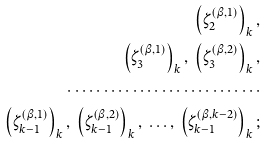<formula> <loc_0><loc_0><loc_500><loc_500>\left ( \zeta _ { 2 } ^ { ( \beta , 1 ) } \right ) _ { k } , \\ \left ( \zeta _ { 3 } ^ { ( \beta , 1 ) } \right ) _ { k } , \ \left ( \zeta _ { 3 } ^ { ( \beta , 2 ) } \right ) _ { k } , \\ \cdots \cdots \cdots \cdots \cdots \cdots \cdots \cdots \cdots \\ \left ( \zeta _ { k - 1 } ^ { ( \beta , 1 ) } \right ) _ { k } , \ \left ( \zeta _ { k - 1 } ^ { ( \beta , 2 ) } \right ) _ { k } , \ \dots , \ \left ( \zeta _ { k - 1 } ^ { ( \beta , k - 2 ) } \right ) _ { k } ;</formula> 